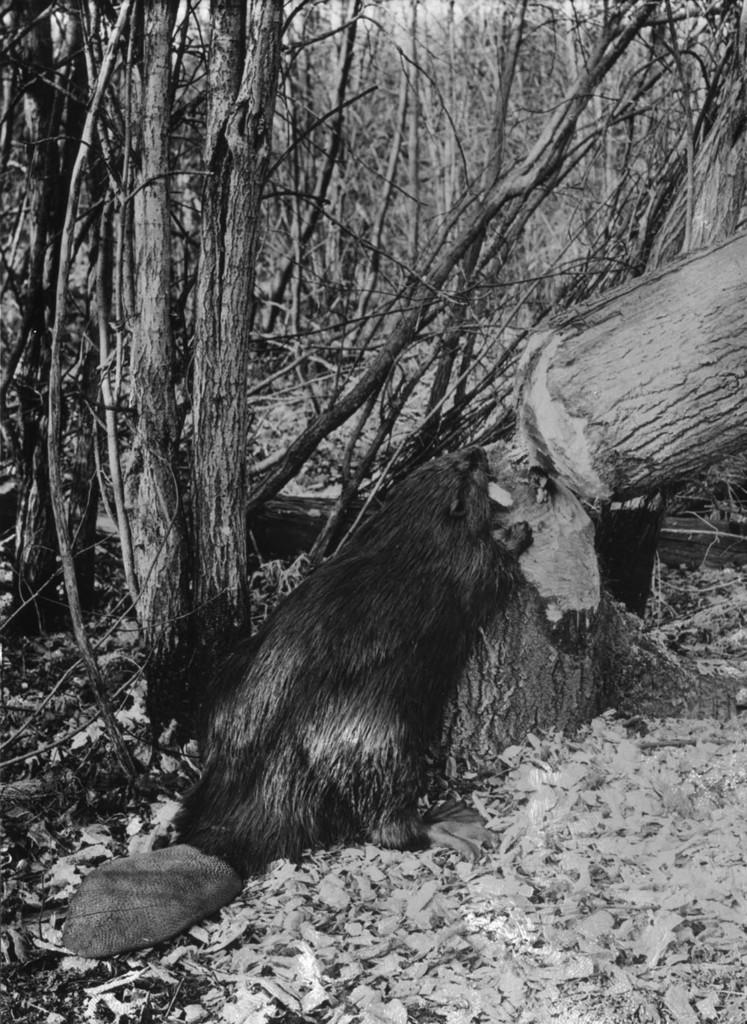What is the primary feature of the image? The primary feature of the image is the presence of many trees. What is the color scheme of the image? The image is in black and white. What type of rake is being used to clear the pollution in the image? There is no rake or indication of pollution present in the image; it features many trees in black and white. 